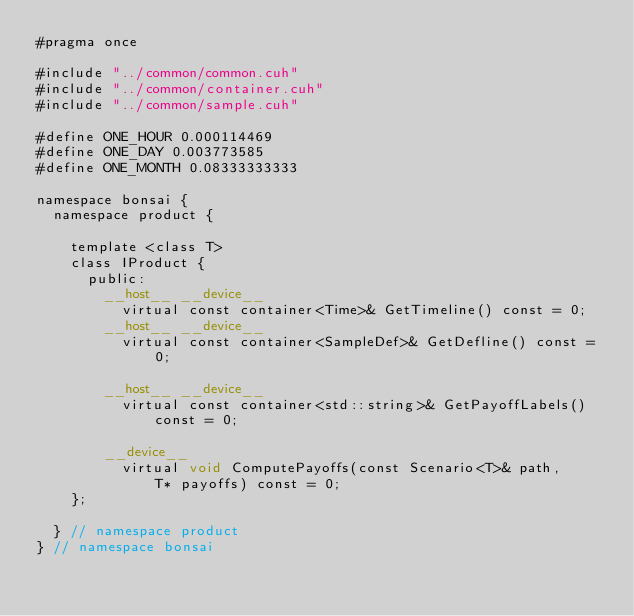Convert code to text. <code><loc_0><loc_0><loc_500><loc_500><_Cuda_>#pragma once

#include "../common/common.cuh"
#include "../common/container.cuh"
#include "../common/sample.cuh"

#define ONE_HOUR 0.000114469
#define ONE_DAY 0.003773585
#define ONE_MONTH 0.08333333333

namespace bonsai {
  namespace product {

    template <class T>
    class IProduct {
      public:
        __host__ __device__
          virtual const container<Time>& GetTimeline() const = 0; 
        __host__ __device__
          virtual const container<SampleDef>& GetDefline() const = 0;

        __host__ __device__
          virtual const container<std::string>& GetPayoffLabels() const = 0;

        __device__
          virtual void ComputePayoffs(const Scenario<T>& path,
              T* payoffs) const = 0;
    };

  } // namespace product
} // namespace bonsai
</code> 